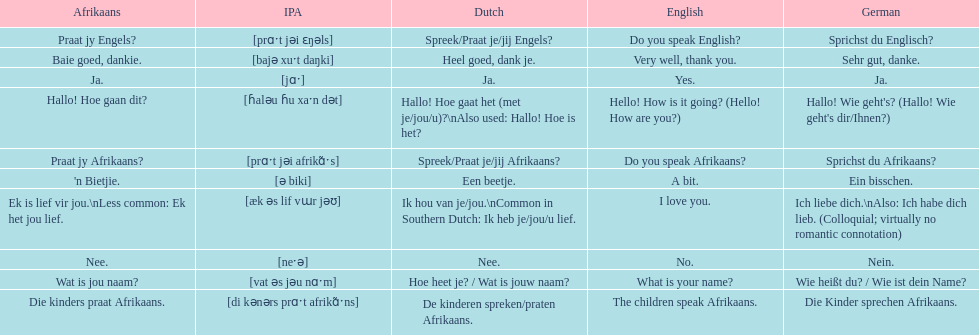How do you say 'i love you' in afrikaans? Ek is lief vir jou. 